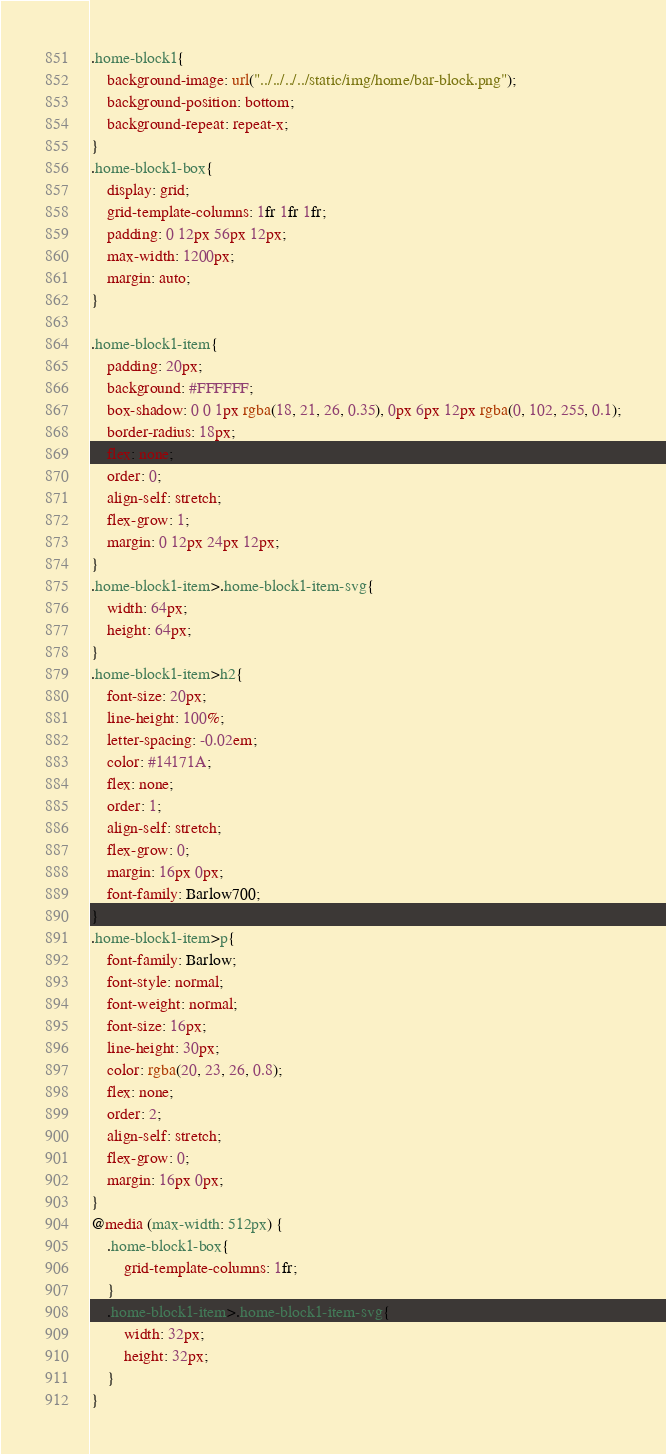Convert code to text. <code><loc_0><loc_0><loc_500><loc_500><_CSS_>.home-block1{
    background-image: url("../../../../static/img/home/bar-block.png");
    background-position: bottom;
    background-repeat: repeat-x;
}
.home-block1-box{
    display: grid;
    grid-template-columns: 1fr 1fr 1fr;
    padding: 0 12px 56px 12px;
    max-width: 1200px;
    margin: auto;
}

.home-block1-item{
    padding: 20px;
    background: #FFFFFF;
    box-shadow: 0 0 1px rgba(18, 21, 26, 0.35), 0px 6px 12px rgba(0, 102, 255, 0.1);
    border-radius: 18px;
    flex: none;
    order: 0;
    align-self: stretch;
    flex-grow: 1;
    margin: 0 12px 24px 12px;
}
.home-block1-item>.home-block1-item-svg{
    width: 64px;
    height: 64px;
}
.home-block1-item>h2{
    font-size: 20px;
    line-height: 100%;
    letter-spacing: -0.02em;
    color: #14171A;
    flex: none;
    order: 1;
    align-self: stretch;
    flex-grow: 0;
    margin: 16px 0px;
    font-family: Barlow700;
}
.home-block1-item>p{
    font-family: Barlow;
    font-style: normal;
    font-weight: normal;
    font-size: 16px;
    line-height: 30px;
    color: rgba(20, 23, 26, 0.8);
    flex: none;
    order: 2;
    align-self: stretch;
    flex-grow: 0;
    margin: 16px 0px;
}
@media (max-width: 512px) {
    .home-block1-box{
        grid-template-columns: 1fr;
    }
    .home-block1-item>.home-block1-item-svg{
        width: 32px;
        height: 32px;
    }
}
</code> 